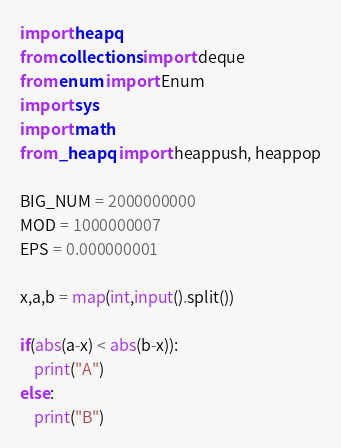<code> <loc_0><loc_0><loc_500><loc_500><_Python_>import heapq
from collections import deque
from enum import Enum
import sys
import math
from _heapq import heappush, heappop

BIG_NUM = 2000000000
MOD = 1000000007
EPS = 0.000000001

x,a,b = map(int,input().split())

if(abs(a-x) < abs(b-x)):
    print("A")
else:
    print("B")</code> 